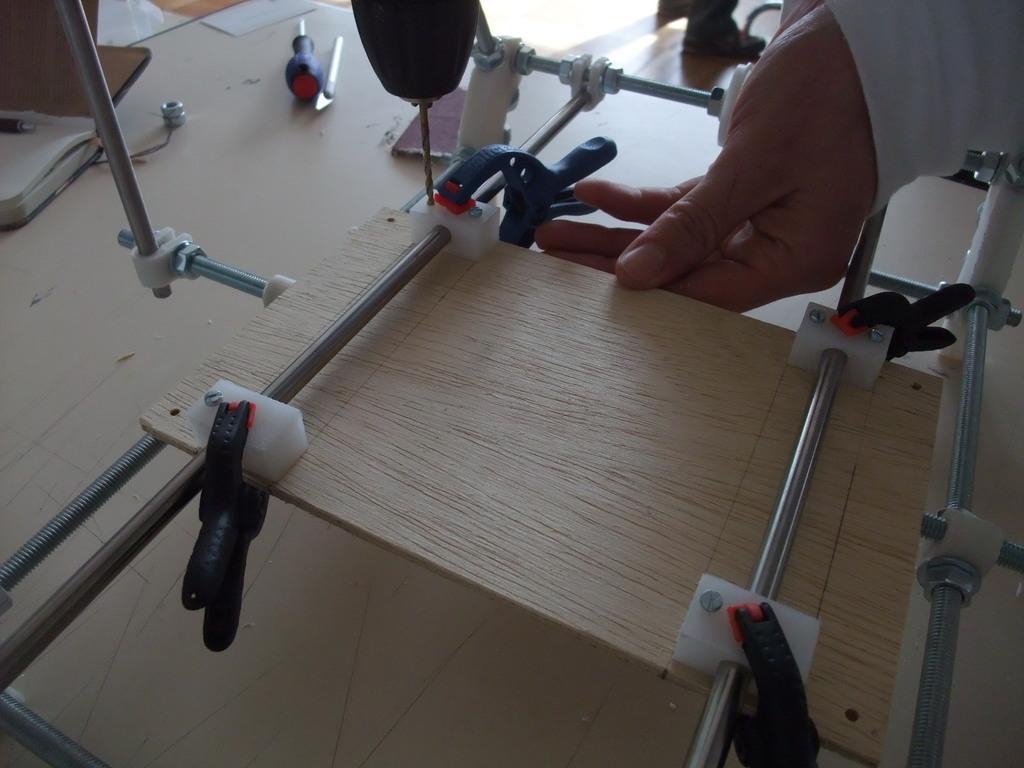Can you describe this image briefly? In this image we can see a wooden object with clips. There are steel rods. And there is a surface. On that there is a book with pen, tools and some other objects. Also we can see hand of a person holding wooden object. 